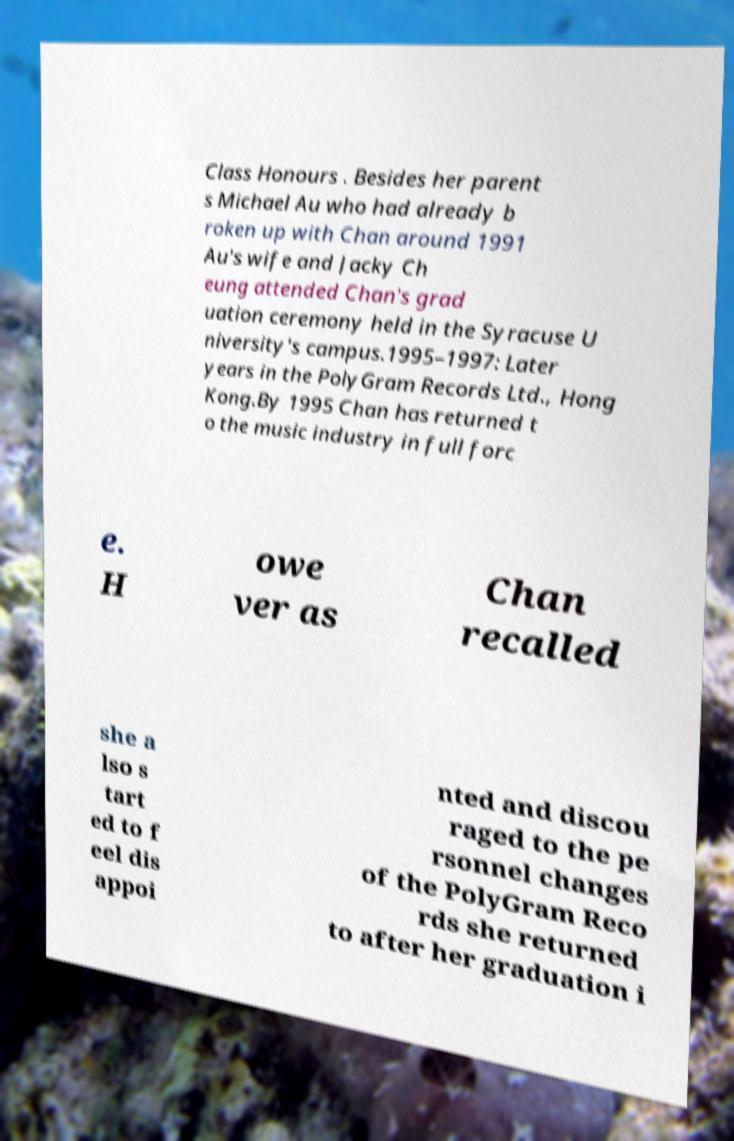I need the written content from this picture converted into text. Can you do that? Class Honours . Besides her parent s Michael Au who had already b roken up with Chan around 1991 Au's wife and Jacky Ch eung attended Chan's grad uation ceremony held in the Syracuse U niversity's campus.1995–1997: Later years in the PolyGram Records Ltd., Hong Kong.By 1995 Chan has returned t o the music industry in full forc e. H owe ver as Chan recalled she a lso s tart ed to f eel dis appoi nted and discou raged to the pe rsonnel changes of the PolyGram Reco rds she returned to after her graduation i 